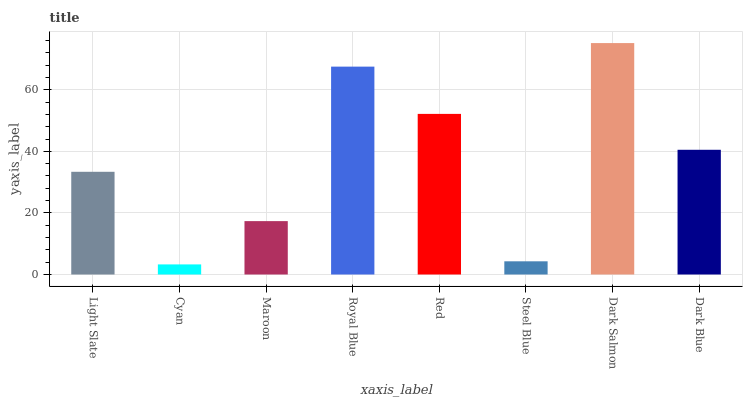Is Cyan the minimum?
Answer yes or no. Yes. Is Dark Salmon the maximum?
Answer yes or no. Yes. Is Maroon the minimum?
Answer yes or no. No. Is Maroon the maximum?
Answer yes or no. No. Is Maroon greater than Cyan?
Answer yes or no. Yes. Is Cyan less than Maroon?
Answer yes or no. Yes. Is Cyan greater than Maroon?
Answer yes or no. No. Is Maroon less than Cyan?
Answer yes or no. No. Is Dark Blue the high median?
Answer yes or no. Yes. Is Light Slate the low median?
Answer yes or no. Yes. Is Red the high median?
Answer yes or no. No. Is Steel Blue the low median?
Answer yes or no. No. 